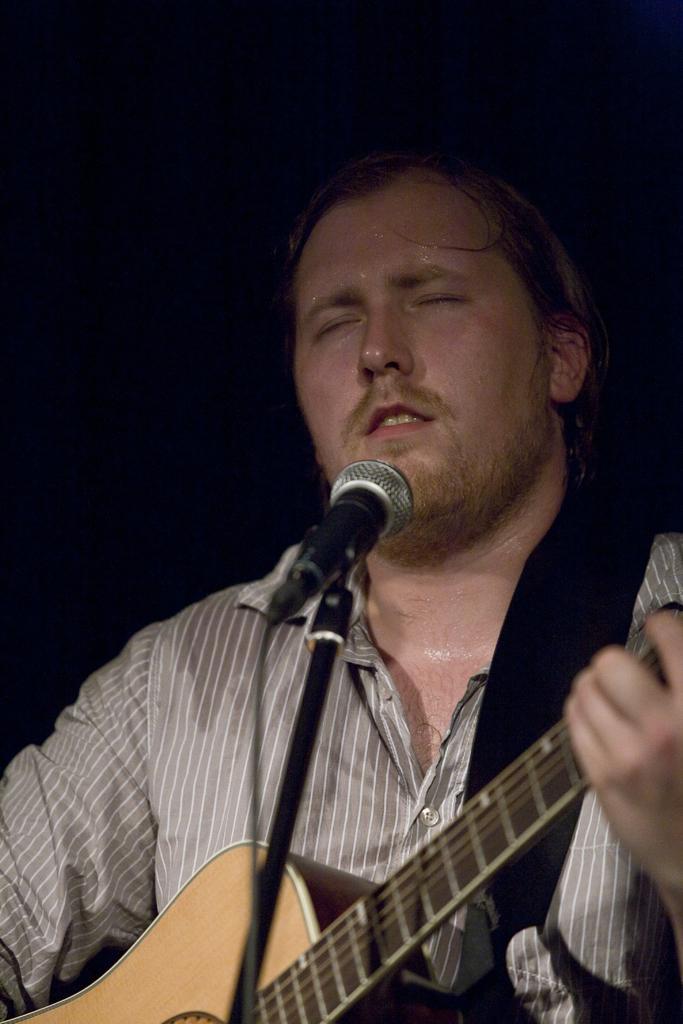In one or two sentences, can you explain what this image depicts? In this image, There is a person in front of this mic and playing a guitar. This person is wearing clothes. 